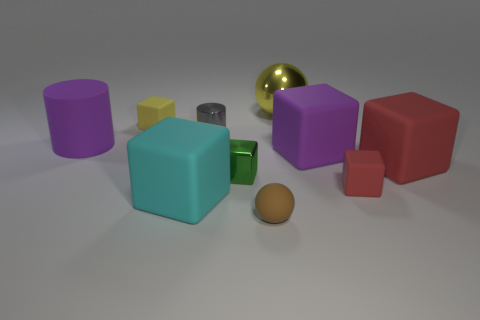There is a large purple rubber thing that is on the right side of the big cyan matte object; does it have the same shape as the tiny brown rubber thing?
Make the answer very short. No. There is a block that is the same color as the big metal ball; what size is it?
Keep it short and to the point. Small. What number of purple things are either small things or shiny spheres?
Provide a succinct answer. 0. How many other objects are the same shape as the tiny green metal object?
Provide a short and direct response. 5. There is a thing that is both behind the small gray metallic object and on the left side of the cyan thing; what is its shape?
Provide a succinct answer. Cube. Are there any small red things behind the cyan rubber block?
Make the answer very short. Yes. There is another object that is the same shape as the yellow shiny object; what size is it?
Offer a very short reply. Small. Is there anything else that has the same size as the gray object?
Ensure brevity in your answer.  Yes. Is the shape of the small brown thing the same as the tiny green metal thing?
Give a very brief answer. No. There is a brown rubber thing that is left of the purple matte thing that is on the right side of the matte cylinder; how big is it?
Keep it short and to the point. Small. 